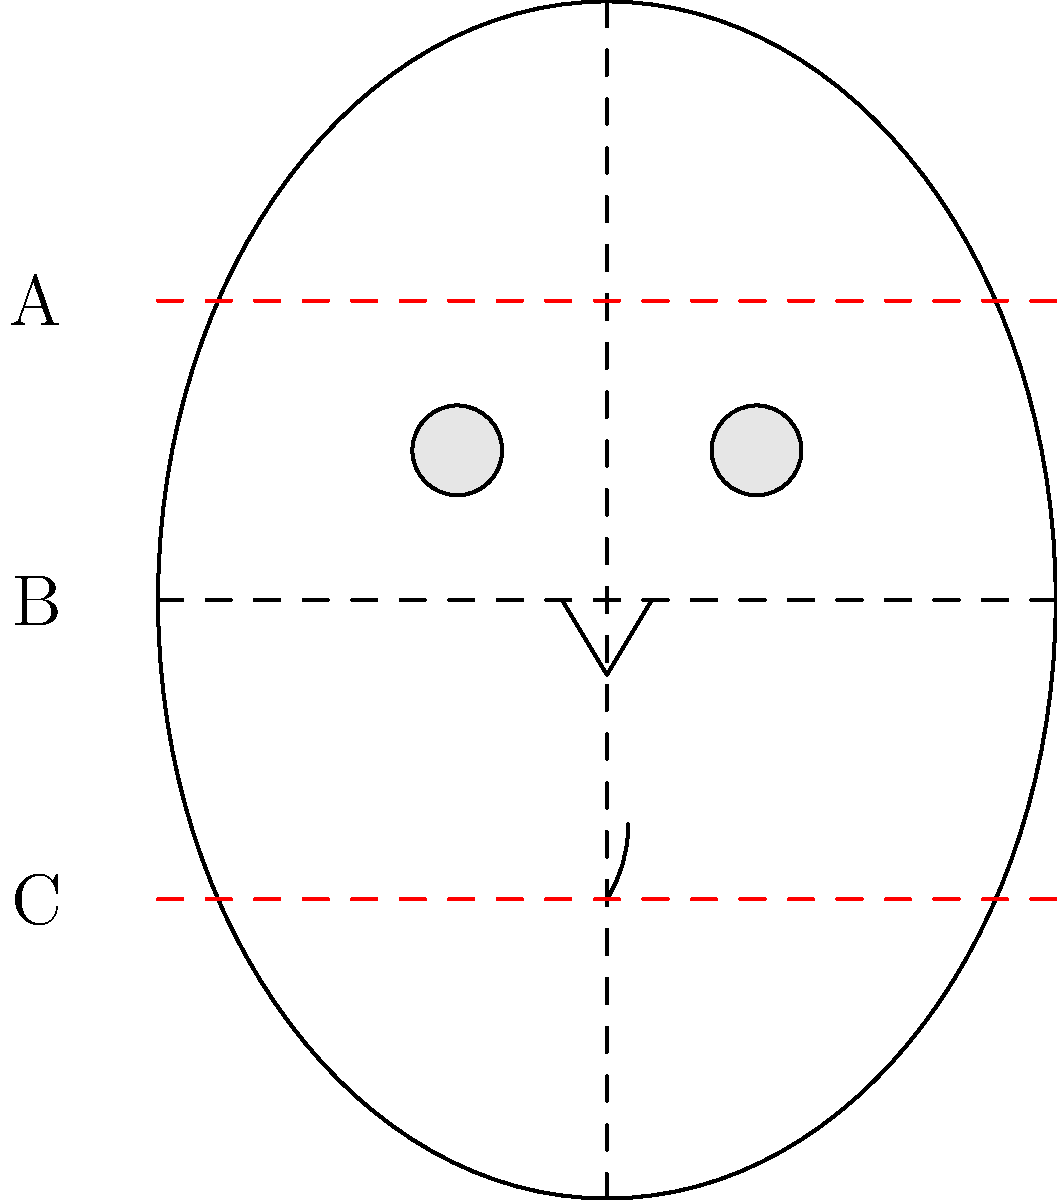In portrait drawing, artists often use the concept of facial thirds to achieve proper proportions. Looking at the diagram of George Clooney's face, which measurement represents the middle third of the face? To understand facial proportions in portrait drawing, artists typically divide the face into thirds:

1. The first step is to identify the hairline, which marks the top of the face.
2. The bottom of the face is marked by the chin.
3. The face is then divided into three equal parts:
   - Top third: From the hairline to the eyebrows
   - Middle third: From the eyebrows to the bottom of the nose
   - Bottom third: From the bottom of the nose to the chin

In the diagram:
- Line A represents the eyebrow level
- Line B represents the center of the eyes and ears
- Line C represents the bottom of the nose

The middle third of the face is the area between the eyebrows and the bottom of the nose. This corresponds to the space between lines A and C in the diagram.

As an aspiring artist and George Clooney fan, recognizing these proportions is crucial for capturing his likeness accurately. The middle third is particularly important as it encompasses key features like the eyes and nose, which are essential in portraying Clooney's characteristic charm.
Answer: A to C 